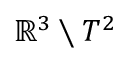<formula> <loc_0><loc_0><loc_500><loc_500>\mathbb { R } ^ { 3 } \ T ^ { 2 }</formula> 